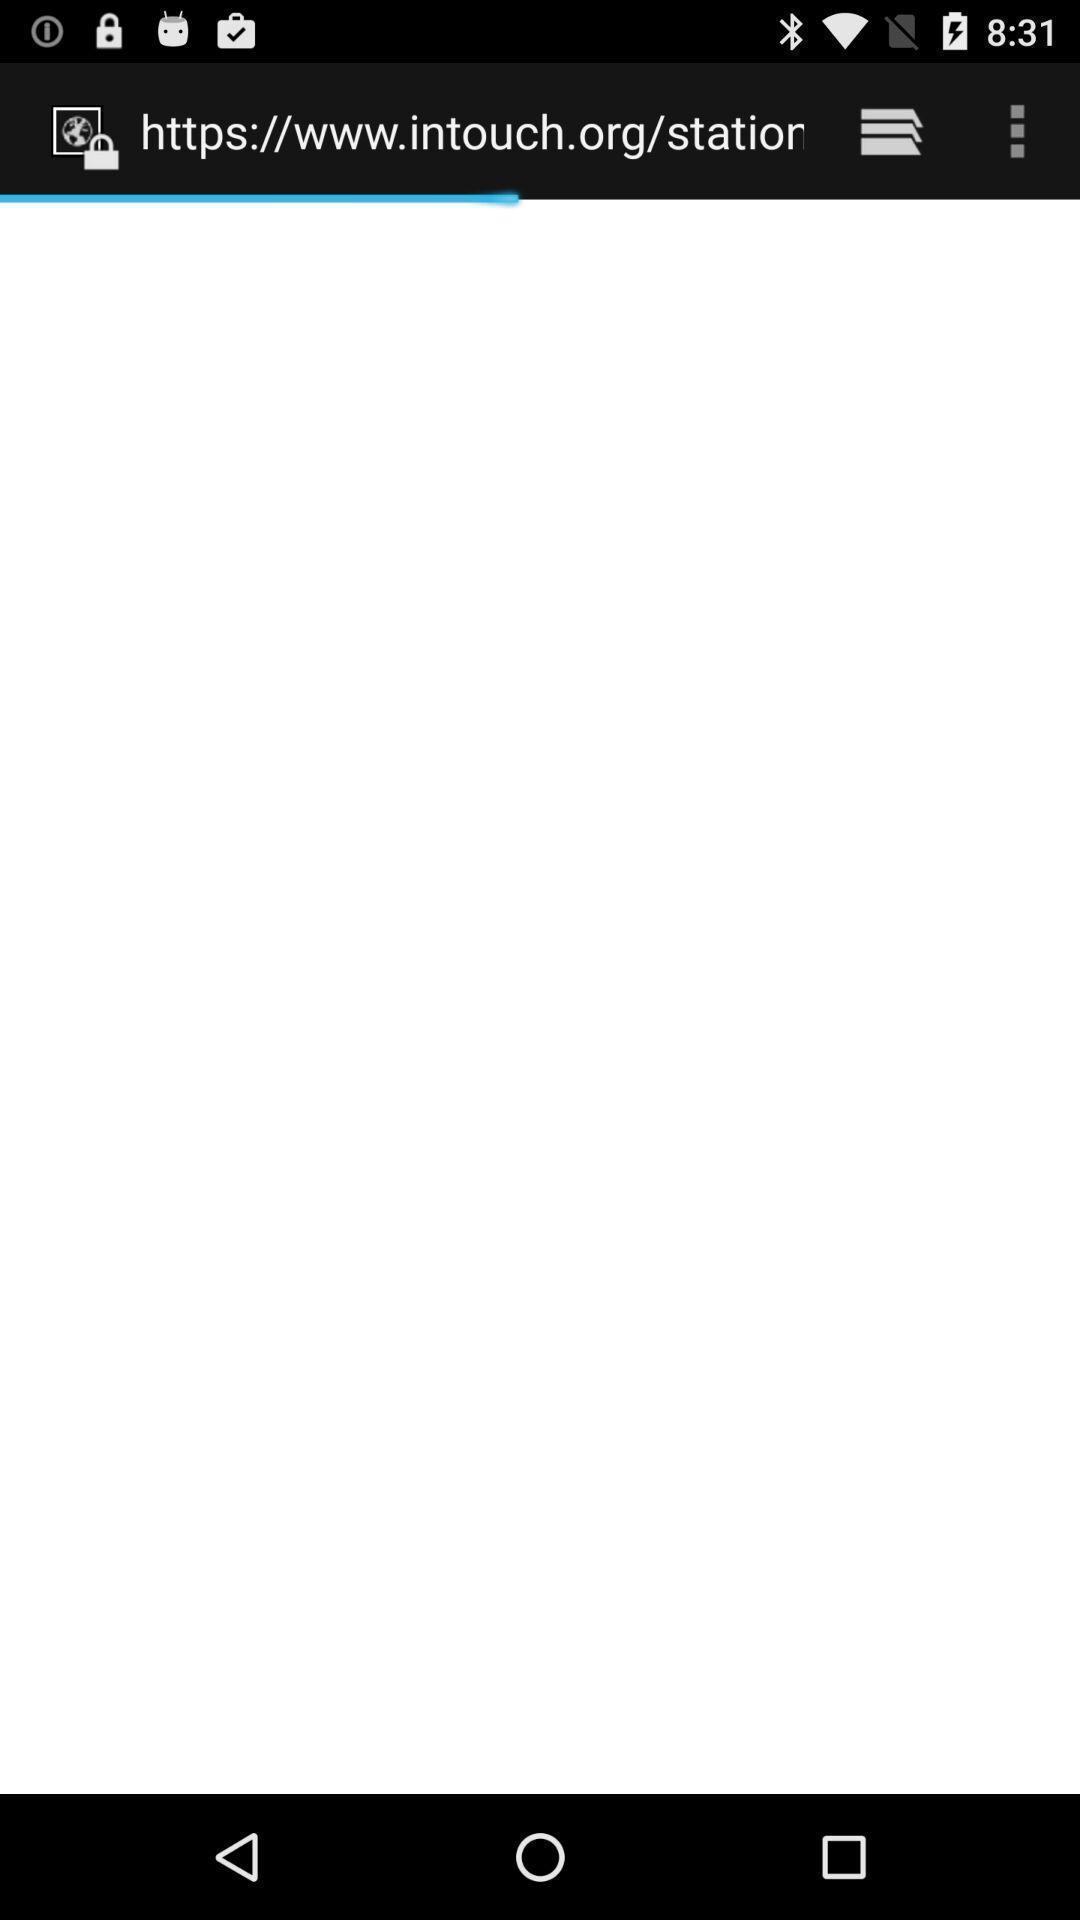Please provide a description for this image. Screen showing web address. 